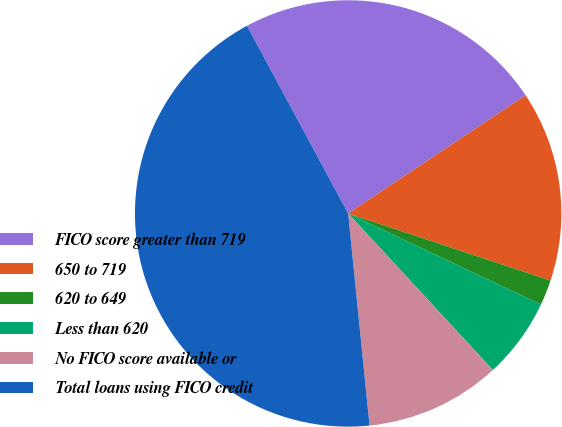Convert chart to OTSL. <chart><loc_0><loc_0><loc_500><loc_500><pie_chart><fcel>FICO score greater than 719<fcel>650 to 719<fcel>620 to 649<fcel>Less than 620<fcel>No FICO score available or<fcel>Total loans using FICO credit<nl><fcel>23.52%<fcel>14.46%<fcel>1.92%<fcel>6.1%<fcel>10.28%<fcel>43.73%<nl></chart> 